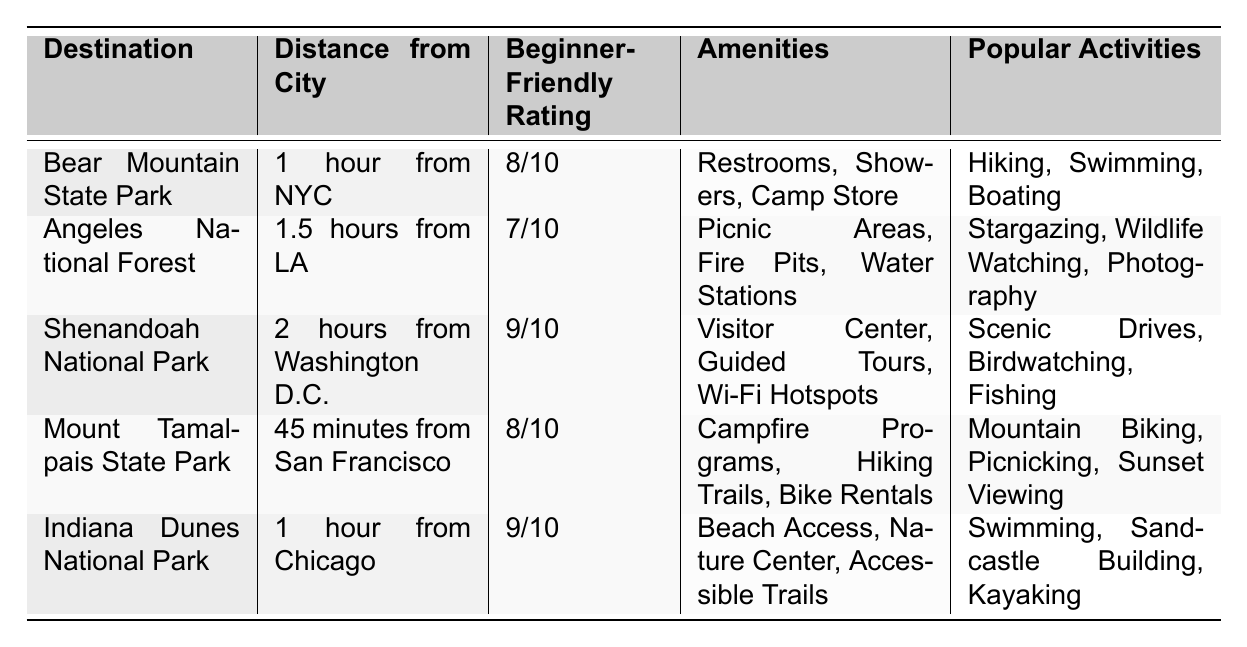What is the distance from San Francisco to Mount Tamalpais State Park? The table states that Mount Tamalpais State Park is located 45 minutes from San Francisco.
Answer: 45 minutes Which camping destination has the highest beginner-friendly rating? By comparing the ratings, Shenandoah National Park has a rating of 9/10, which is the highest among the listed destinations.
Answer: Shenandoah National Park Is there restroom access at Bear Mountain State Park? The table lists Bear Mountain State Park as having restrooms among its amenities, indicating that there is restroom access.
Answer: Yes What popular activities can you do at Indiana Dunes National Park? The table shows that popular activities at Indiana Dunes National Park include swimming, sandcastle building, and kayaking.
Answer: Swimming, sandcastle building, kayaking Which destination is located 1.5 hours from LA and what is its beginner-friendly rating? Angeles National Forest is located 1.5 hours from LA, and it has a beginner-friendly rating of 7/10 according to the table.
Answer: Angeles National Forest, 7/10 Compare the beginner-friendly ratings of the two parks: Bear Mountain State Park and Mount Tamalpais State Park. Bear Mountain State Park has an 8/10 rating, while Mount Tamalpais State Park also has 8/10, indicating they have the same beginner-friendly rating.
Answer: Both have 8/10 What amenities does Shenandoah National Park offer? The table lists amenities for Shenandoah National Park as a visitor center, guided tours, and Wi-Fi hotspots.
Answer: Visitor center, guided tours, Wi-Fi hotspots Are there any destinations listed that offer beach access? The table indicates that Indiana Dunes National Park offers beach access as one of its amenities.
Answer: Yes, at Indiana Dunes National Park What is the total distance from NYC to Bear Mountain State Park and from Chicago to Indiana Dunes National Park combined? The distance from NYC to Bear Mountain State Park is 1 hour, and from Chicago to Indiana Dunes National Park, it is also 1 hour. Totaling these gives 1 + 1 = 2 hours.
Answer: 2 hours What activities can you participate in at Angeles National Forest? According to the table, popular activities at Angeles National Forest include stargazing, wildlife watching, and photography.
Answer: Stargazing, wildlife watching, photography Which park is closest to Washington D.C. and how long does it take to get there? Shenandoah National Park is the closest to Washington D.C., taking 2 hours to reach, as mentioned in the table.
Answer: Shenandoah National Park, 2 hours 